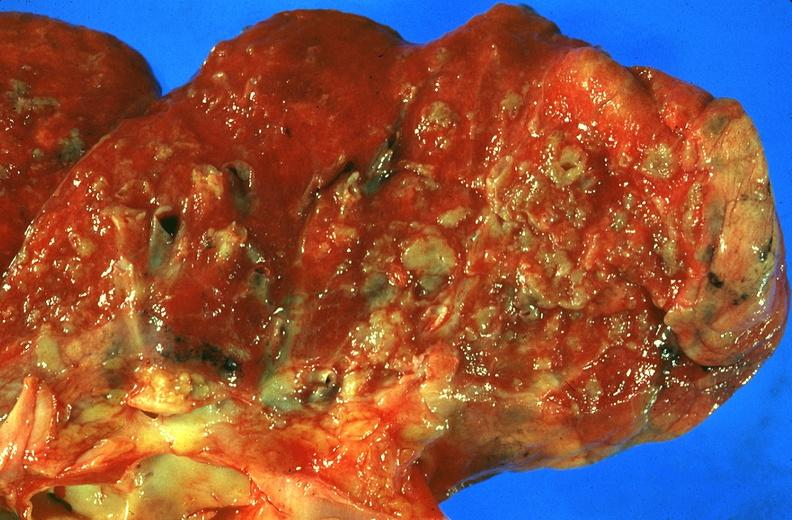does this image show lung, sarcoidosis?
Answer the question using a single word or phrase. Yes 